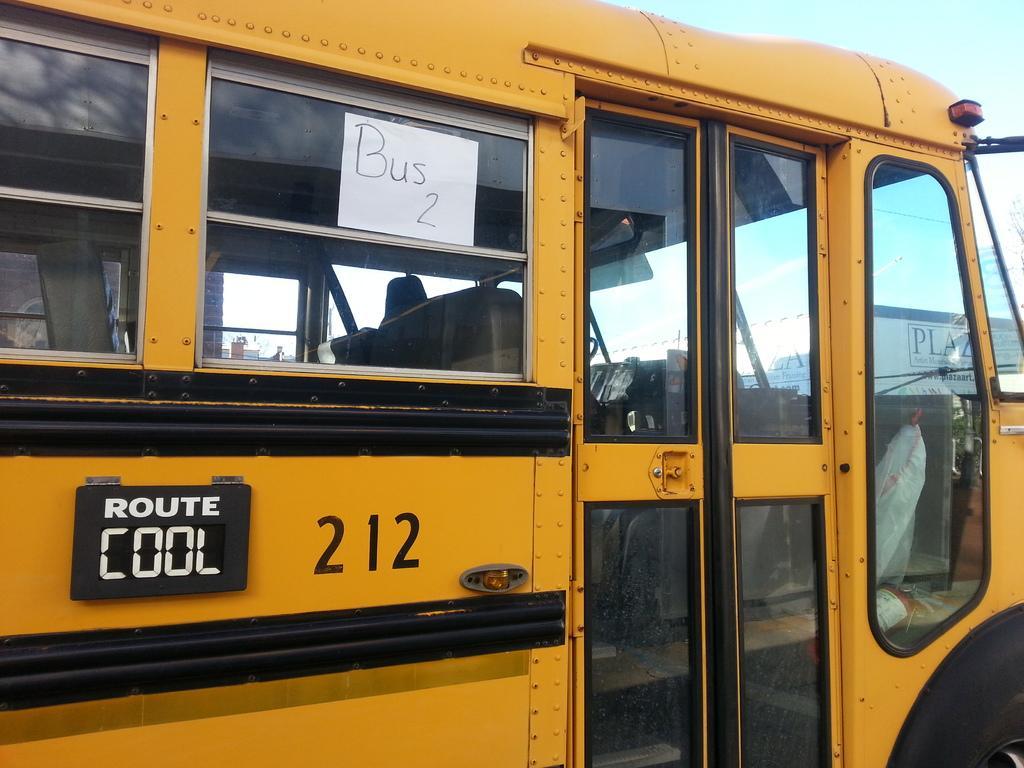Please provide a concise description of this image. In this picture, we see a bus in yellow and blue color. We see a board in black color with text written as "ROUTE COOL" and we see the number written as "212". We see a white paper is pasted on the glass and it is written as "BUS 2". On the right side, we see a building in white color. At the top, we see the sky. 